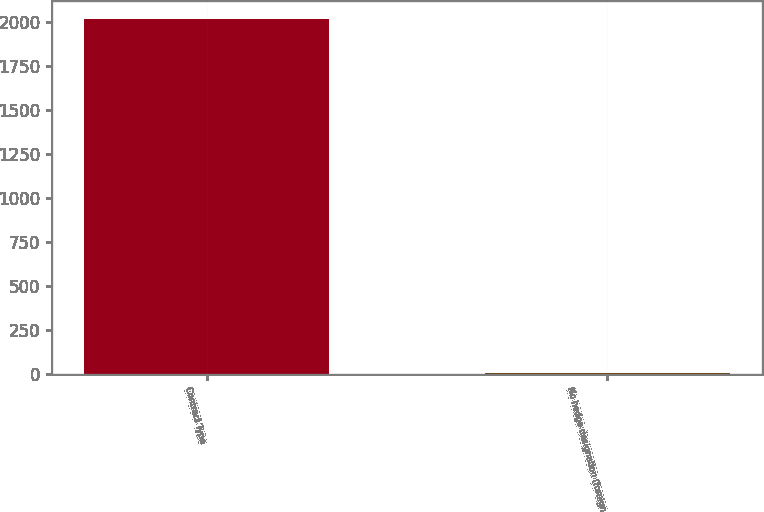<chart> <loc_0><loc_0><loc_500><loc_500><bar_chart><fcel>Contract Type<fcel>No hedge designation (foreign<nl><fcel>2014<fcel>5<nl></chart> 